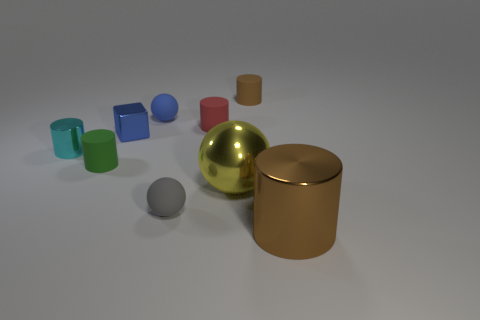Subtract all small green rubber cylinders. How many cylinders are left? 4 Subtract 2 cylinders. How many cylinders are left? 3 Subtract all cyan cylinders. How many cylinders are left? 4 Subtract all gray cylinders. Subtract all yellow blocks. How many cylinders are left? 5 Subtract all cubes. How many objects are left? 8 Subtract 0 gray cylinders. How many objects are left? 9 Subtract all small cylinders. Subtract all tiny cubes. How many objects are left? 4 Add 3 large shiny things. How many large shiny things are left? 5 Add 9 gray spheres. How many gray spheres exist? 10 